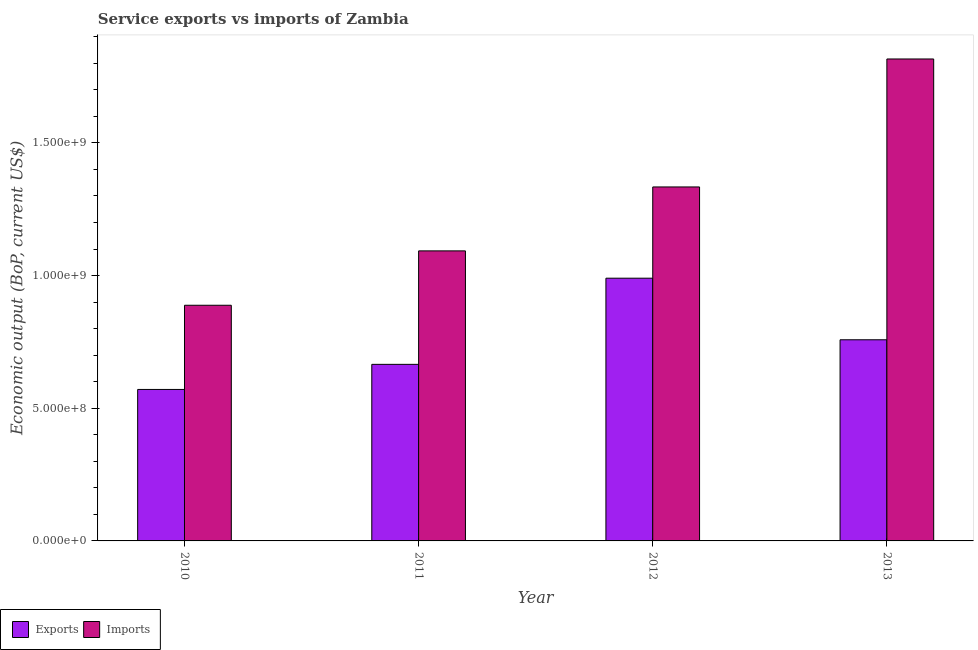How many different coloured bars are there?
Your response must be concise. 2. How many groups of bars are there?
Ensure brevity in your answer.  4. Are the number of bars per tick equal to the number of legend labels?
Provide a short and direct response. Yes. Are the number of bars on each tick of the X-axis equal?
Offer a terse response. Yes. How many bars are there on the 2nd tick from the left?
Your response must be concise. 2. How many bars are there on the 1st tick from the right?
Keep it short and to the point. 2. In how many cases, is the number of bars for a given year not equal to the number of legend labels?
Provide a short and direct response. 0. What is the amount of service exports in 2012?
Offer a terse response. 9.90e+08. Across all years, what is the maximum amount of service exports?
Provide a succinct answer. 9.90e+08. Across all years, what is the minimum amount of service imports?
Your answer should be compact. 8.88e+08. In which year was the amount of service exports minimum?
Provide a succinct answer. 2010. What is the total amount of service imports in the graph?
Keep it short and to the point. 5.13e+09. What is the difference between the amount of service exports in 2010 and that in 2011?
Your answer should be very brief. -9.46e+07. What is the difference between the amount of service imports in 2013 and the amount of service exports in 2012?
Keep it short and to the point. 4.82e+08. What is the average amount of service imports per year?
Offer a terse response. 1.28e+09. In the year 2012, what is the difference between the amount of service imports and amount of service exports?
Provide a succinct answer. 0. What is the ratio of the amount of service exports in 2011 to that in 2012?
Ensure brevity in your answer.  0.67. What is the difference between the highest and the second highest amount of service imports?
Your response must be concise. 4.82e+08. What is the difference between the highest and the lowest amount of service exports?
Give a very brief answer. 4.19e+08. In how many years, is the amount of service imports greater than the average amount of service imports taken over all years?
Offer a very short reply. 2. What does the 1st bar from the left in 2011 represents?
Give a very brief answer. Exports. What does the 1st bar from the right in 2012 represents?
Ensure brevity in your answer.  Imports. How many bars are there?
Provide a short and direct response. 8. Are all the bars in the graph horizontal?
Your answer should be compact. No. How many years are there in the graph?
Offer a very short reply. 4. How are the legend labels stacked?
Offer a very short reply. Horizontal. What is the title of the graph?
Keep it short and to the point. Service exports vs imports of Zambia. What is the label or title of the X-axis?
Provide a short and direct response. Year. What is the label or title of the Y-axis?
Make the answer very short. Economic output (BoP, current US$). What is the Economic output (BoP, current US$) in Exports in 2010?
Keep it short and to the point. 5.71e+08. What is the Economic output (BoP, current US$) in Imports in 2010?
Your answer should be compact. 8.88e+08. What is the Economic output (BoP, current US$) in Exports in 2011?
Give a very brief answer. 6.65e+08. What is the Economic output (BoP, current US$) of Imports in 2011?
Make the answer very short. 1.09e+09. What is the Economic output (BoP, current US$) in Exports in 2012?
Your response must be concise. 9.90e+08. What is the Economic output (BoP, current US$) of Imports in 2012?
Your response must be concise. 1.33e+09. What is the Economic output (BoP, current US$) in Exports in 2013?
Your answer should be compact. 7.58e+08. What is the Economic output (BoP, current US$) in Imports in 2013?
Your answer should be very brief. 1.82e+09. Across all years, what is the maximum Economic output (BoP, current US$) of Exports?
Make the answer very short. 9.90e+08. Across all years, what is the maximum Economic output (BoP, current US$) of Imports?
Give a very brief answer. 1.82e+09. Across all years, what is the minimum Economic output (BoP, current US$) of Exports?
Make the answer very short. 5.71e+08. Across all years, what is the minimum Economic output (BoP, current US$) in Imports?
Ensure brevity in your answer.  8.88e+08. What is the total Economic output (BoP, current US$) in Exports in the graph?
Provide a short and direct response. 2.98e+09. What is the total Economic output (BoP, current US$) of Imports in the graph?
Make the answer very short. 5.13e+09. What is the difference between the Economic output (BoP, current US$) of Exports in 2010 and that in 2011?
Your answer should be very brief. -9.46e+07. What is the difference between the Economic output (BoP, current US$) of Imports in 2010 and that in 2011?
Offer a terse response. -2.05e+08. What is the difference between the Economic output (BoP, current US$) of Exports in 2010 and that in 2012?
Your response must be concise. -4.19e+08. What is the difference between the Economic output (BoP, current US$) in Imports in 2010 and that in 2012?
Provide a short and direct response. -4.46e+08. What is the difference between the Economic output (BoP, current US$) in Exports in 2010 and that in 2013?
Keep it short and to the point. -1.87e+08. What is the difference between the Economic output (BoP, current US$) in Imports in 2010 and that in 2013?
Your response must be concise. -9.28e+08. What is the difference between the Economic output (BoP, current US$) in Exports in 2011 and that in 2012?
Offer a terse response. -3.25e+08. What is the difference between the Economic output (BoP, current US$) in Imports in 2011 and that in 2012?
Offer a terse response. -2.41e+08. What is the difference between the Economic output (BoP, current US$) in Exports in 2011 and that in 2013?
Keep it short and to the point. -9.26e+07. What is the difference between the Economic output (BoP, current US$) in Imports in 2011 and that in 2013?
Your answer should be compact. -7.23e+08. What is the difference between the Economic output (BoP, current US$) of Exports in 2012 and that in 2013?
Provide a short and direct response. 2.32e+08. What is the difference between the Economic output (BoP, current US$) in Imports in 2012 and that in 2013?
Your answer should be very brief. -4.82e+08. What is the difference between the Economic output (BoP, current US$) in Exports in 2010 and the Economic output (BoP, current US$) in Imports in 2011?
Make the answer very short. -5.22e+08. What is the difference between the Economic output (BoP, current US$) in Exports in 2010 and the Economic output (BoP, current US$) in Imports in 2012?
Provide a succinct answer. -7.63e+08. What is the difference between the Economic output (BoP, current US$) of Exports in 2010 and the Economic output (BoP, current US$) of Imports in 2013?
Offer a very short reply. -1.25e+09. What is the difference between the Economic output (BoP, current US$) of Exports in 2011 and the Economic output (BoP, current US$) of Imports in 2012?
Make the answer very short. -6.69e+08. What is the difference between the Economic output (BoP, current US$) in Exports in 2011 and the Economic output (BoP, current US$) in Imports in 2013?
Ensure brevity in your answer.  -1.15e+09. What is the difference between the Economic output (BoP, current US$) in Exports in 2012 and the Economic output (BoP, current US$) in Imports in 2013?
Ensure brevity in your answer.  -8.26e+08. What is the average Economic output (BoP, current US$) in Exports per year?
Ensure brevity in your answer.  7.46e+08. What is the average Economic output (BoP, current US$) of Imports per year?
Give a very brief answer. 1.28e+09. In the year 2010, what is the difference between the Economic output (BoP, current US$) in Exports and Economic output (BoP, current US$) in Imports?
Provide a short and direct response. -3.17e+08. In the year 2011, what is the difference between the Economic output (BoP, current US$) in Exports and Economic output (BoP, current US$) in Imports?
Your response must be concise. -4.28e+08. In the year 2012, what is the difference between the Economic output (BoP, current US$) of Exports and Economic output (BoP, current US$) of Imports?
Your response must be concise. -3.44e+08. In the year 2013, what is the difference between the Economic output (BoP, current US$) in Exports and Economic output (BoP, current US$) in Imports?
Ensure brevity in your answer.  -1.06e+09. What is the ratio of the Economic output (BoP, current US$) in Exports in 2010 to that in 2011?
Offer a terse response. 0.86. What is the ratio of the Economic output (BoP, current US$) in Imports in 2010 to that in 2011?
Make the answer very short. 0.81. What is the ratio of the Economic output (BoP, current US$) of Exports in 2010 to that in 2012?
Provide a short and direct response. 0.58. What is the ratio of the Economic output (BoP, current US$) in Imports in 2010 to that in 2012?
Provide a short and direct response. 0.67. What is the ratio of the Economic output (BoP, current US$) of Exports in 2010 to that in 2013?
Provide a succinct answer. 0.75. What is the ratio of the Economic output (BoP, current US$) in Imports in 2010 to that in 2013?
Your answer should be compact. 0.49. What is the ratio of the Economic output (BoP, current US$) in Exports in 2011 to that in 2012?
Your answer should be compact. 0.67. What is the ratio of the Economic output (BoP, current US$) of Imports in 2011 to that in 2012?
Make the answer very short. 0.82. What is the ratio of the Economic output (BoP, current US$) in Exports in 2011 to that in 2013?
Provide a succinct answer. 0.88. What is the ratio of the Economic output (BoP, current US$) in Imports in 2011 to that in 2013?
Ensure brevity in your answer.  0.6. What is the ratio of the Economic output (BoP, current US$) in Exports in 2012 to that in 2013?
Offer a very short reply. 1.31. What is the ratio of the Economic output (BoP, current US$) of Imports in 2012 to that in 2013?
Offer a terse response. 0.73. What is the difference between the highest and the second highest Economic output (BoP, current US$) of Exports?
Make the answer very short. 2.32e+08. What is the difference between the highest and the second highest Economic output (BoP, current US$) of Imports?
Offer a terse response. 4.82e+08. What is the difference between the highest and the lowest Economic output (BoP, current US$) of Exports?
Your answer should be very brief. 4.19e+08. What is the difference between the highest and the lowest Economic output (BoP, current US$) in Imports?
Your answer should be very brief. 9.28e+08. 